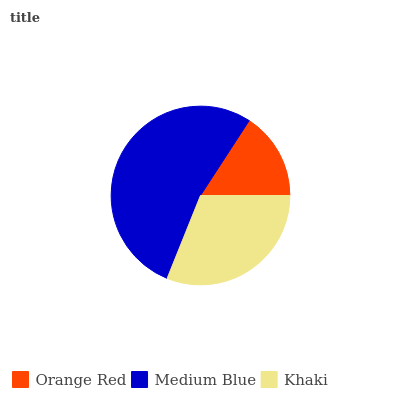Is Orange Red the minimum?
Answer yes or no. Yes. Is Medium Blue the maximum?
Answer yes or no. Yes. Is Khaki the minimum?
Answer yes or no. No. Is Khaki the maximum?
Answer yes or no. No. Is Medium Blue greater than Khaki?
Answer yes or no. Yes. Is Khaki less than Medium Blue?
Answer yes or no. Yes. Is Khaki greater than Medium Blue?
Answer yes or no. No. Is Medium Blue less than Khaki?
Answer yes or no. No. Is Khaki the high median?
Answer yes or no. Yes. Is Khaki the low median?
Answer yes or no. Yes. Is Orange Red the high median?
Answer yes or no. No. Is Medium Blue the low median?
Answer yes or no. No. 